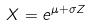Convert formula to latex. <formula><loc_0><loc_0><loc_500><loc_500>X = e ^ { \mu + \sigma Z }</formula> 